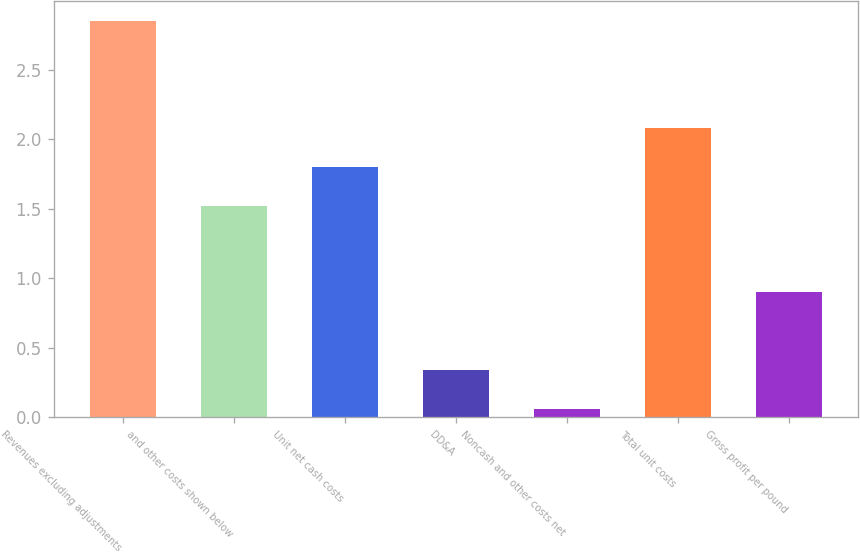<chart> <loc_0><loc_0><loc_500><loc_500><bar_chart><fcel>Revenues excluding adjustments<fcel>and other costs shown below<fcel>Unit net cash costs<fcel>DD&A<fcel>Noncash and other costs net<fcel>Total unit costs<fcel>Gross profit per pound<nl><fcel>2.85<fcel>1.52<fcel>1.8<fcel>0.34<fcel>0.06<fcel>2.08<fcel>0.9<nl></chart> 